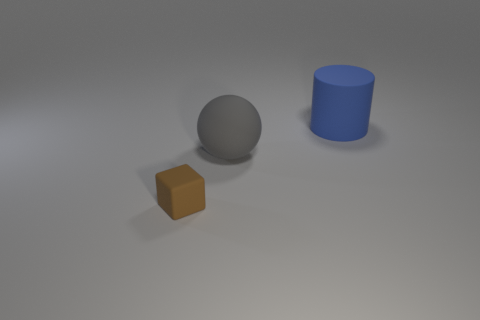The blue object that is the same size as the matte ball is what shape?
Give a very brief answer. Cylinder. Is there a big purple thing of the same shape as the blue object?
Give a very brief answer. No. Is the material of the large gray sphere the same as the thing behind the large gray matte object?
Give a very brief answer. Yes. What is the material of the big object to the left of the matte thing that is right of the gray ball?
Provide a short and direct response. Rubber. Is the number of matte cubes left of the rubber block greater than the number of big purple metal cylinders?
Offer a terse response. No. Is there a big blue rubber object?
Give a very brief answer. Yes. There is a large thing left of the big blue matte object; what color is it?
Offer a very short reply. Gray. There is a blue cylinder that is the same size as the gray rubber thing; what is it made of?
Ensure brevity in your answer.  Rubber. What number of other objects are there of the same material as the big blue cylinder?
Offer a very short reply. 2. The rubber thing that is both right of the matte cube and in front of the blue cylinder is what color?
Your answer should be very brief. Gray. 